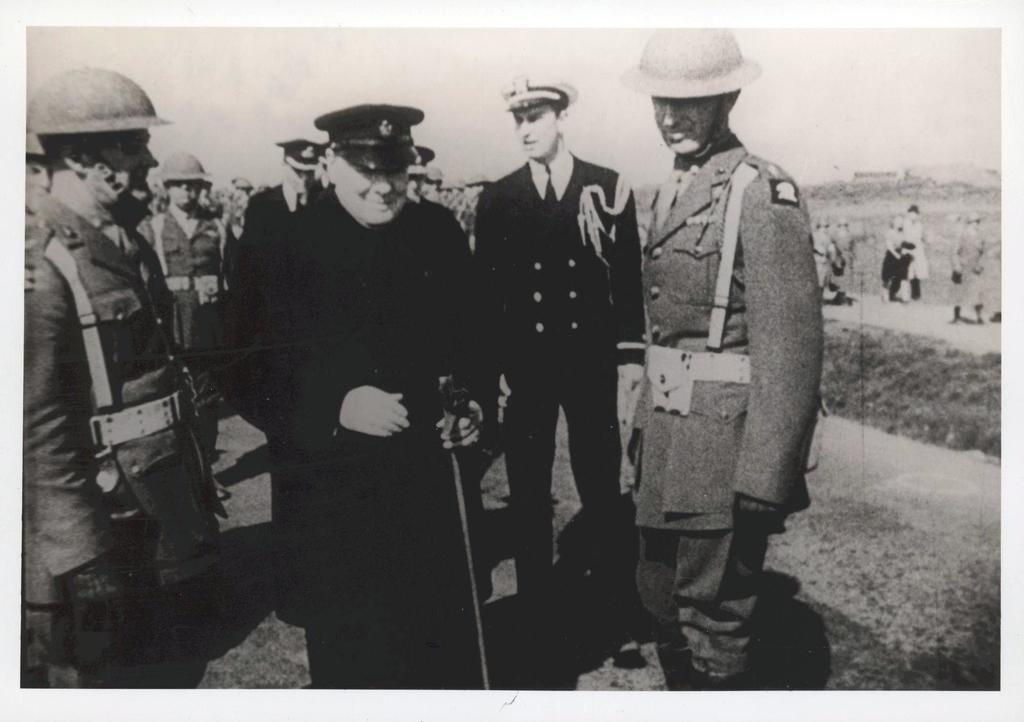What is happening with the people in the image? There is a group of people standing and a group of people walking in the image. What can be seen above the people in the image? The sky is visible at the top of the image. What can be seen below the people in the image? The ground is visible at the bottom of the image. Who is the creator of the sea visible in the image? There is no sea visible in the image, so it is not possible to determine the creator of a sea. 